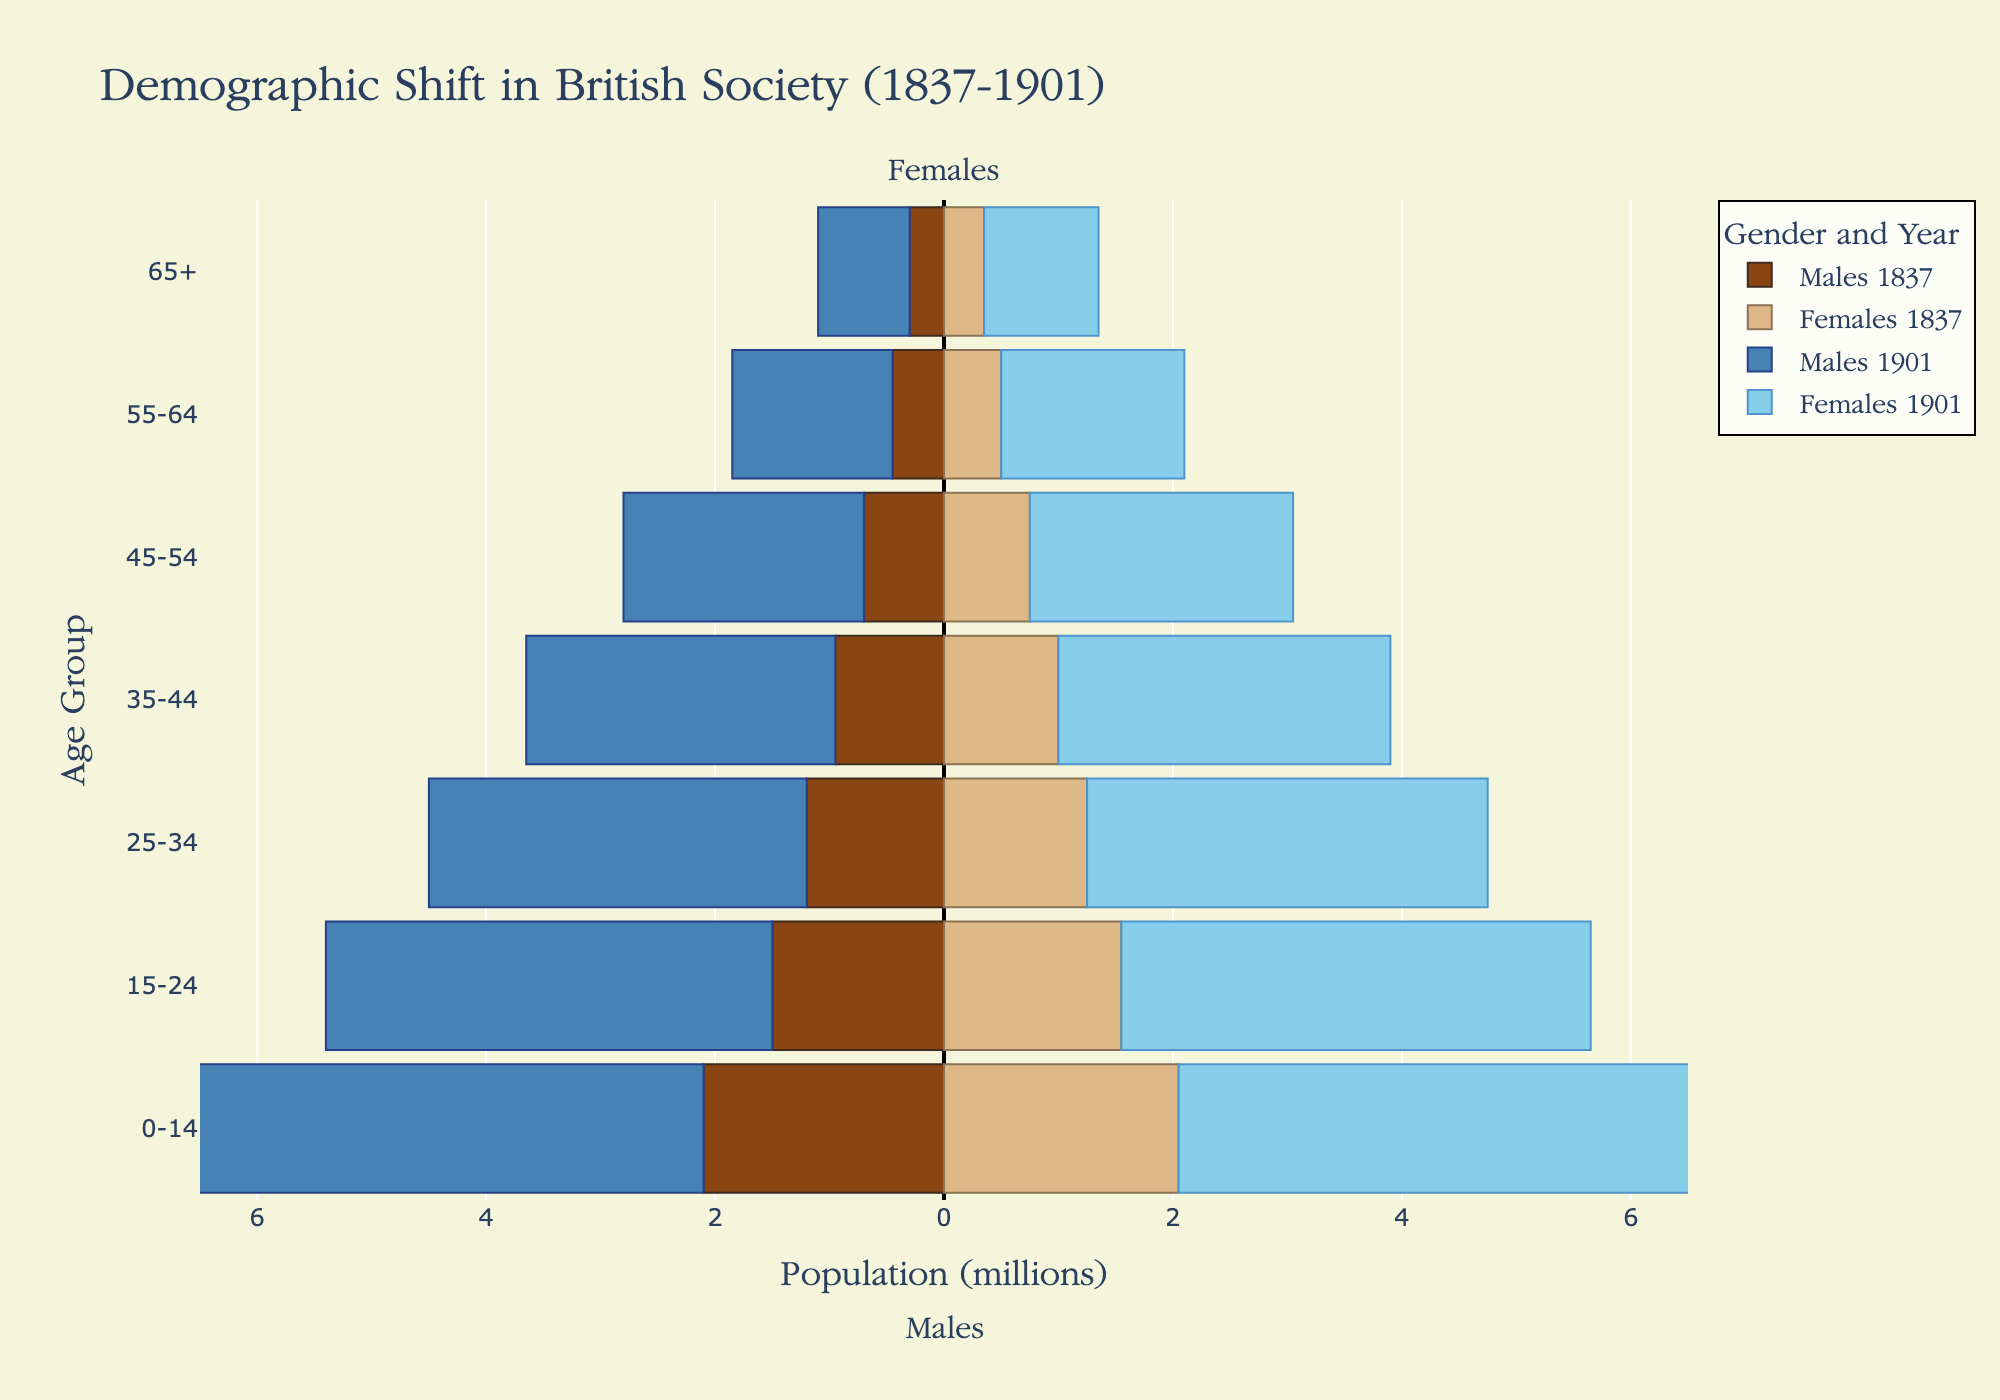What is the title of the figure? The title of the figure is typically displayed prominently at the top of the plot. In this case, it is clearly written.
Answer: Demographic Shift in British Society (1837-1901) Which two colors represent the population data for Males in 1837 and 1901? The color key shows different colors for Males in two different years: brownish hues for 1837 and blueish hues for 1901.
Answer: Brown and Blue What is the age group with the smallest female population in 1837? By observing the lengths of the bars for females in 1837, the shortest bar represents the smallest population. The age group at the bottom of the plot has the smallest bar.
Answer: 65+ For which age groups did the population of Males more than double from 1837 to 1901? Compare the lengths of the bars representing Males in 1837 and 1901 for each age group. If the bar representing 1901 is more than twice the length of the bar for 1837, mark those age groups.
Answer: 0-14, 15-24, 25-34, 35-44, 45-54 Which age group shows the largest increase in population for both Males and Females between 1837 and 1901? Identify the age group with the largest difference in bar lengths between 1837 and 1901 for both Males and Females. This requires visual comparison of each pair of bars.
Answer: 0-14 What is the total female population in 1837 for all age groups combined? Sum the population values for females in 1837 across all age groups: 2050000 + 1550000 + 1250000 + 1000000 + 750000 + 500000 + 350000, then divide by 1,000,000.
Answer: 7.2 million How does the population structure in 1901 show the impact of industrialization compared to 1837? Observing the general shape of the population pyramid for 1901 compared to 1837 shows a broader base and middle, indicating higher birth rates and better survival rates due to improvements like healthcare and living conditions.
Answer: Broader base & middle in 1901 Which demographic (male or female) shows a higher proportional increase in the 65+ age group from 1837 to 1901? Look at the relative difference in the lengths of the bars for the 65+ age group for both males and females between 1837 and 1901. Females show a larger relative increase.
Answer: Females What's the combined population of males and females aged 55-64 in 1901? Sum the population values for males and females in this age group in 1901: 1400000 + 1600000, then divide by 1,000,000.
Answer: 3 million 